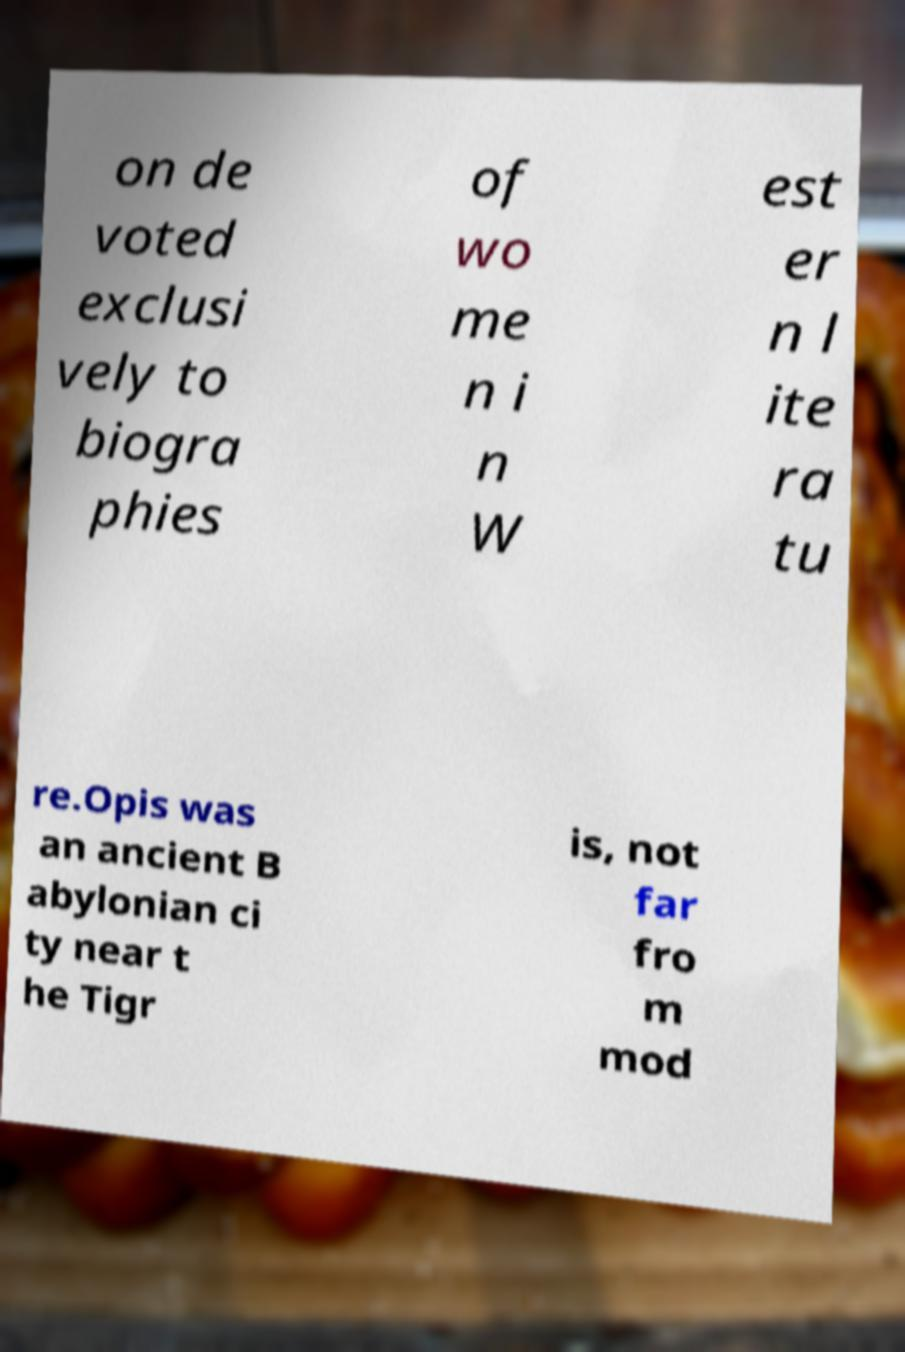For documentation purposes, I need the text within this image transcribed. Could you provide that? on de voted exclusi vely to biogra phies of wo me n i n W est er n l ite ra tu re.Opis was an ancient B abylonian ci ty near t he Tigr is, not far fro m mod 